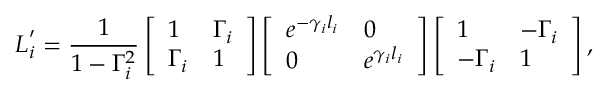Convert formula to latex. <formula><loc_0><loc_0><loc_500><loc_500>L _ { i } ^ { \prime } = \frac { 1 } { 1 - \Gamma _ { i } ^ { 2 } } \left [ \begin{array} { l l } { 1 } & { \Gamma _ { i } } \\ { \Gamma _ { i } } & { 1 } \end{array} \right ] \left [ \begin{array} { l l } { e ^ { - \gamma _ { i } l _ { i } } } & { 0 } \\ { 0 } & { e ^ { \gamma _ { i } l _ { i } } } \end{array} \right ] \left [ \begin{array} { l l } { 1 } & { - \Gamma _ { i } } \\ { - \Gamma _ { i } } & { 1 } \end{array} \right ] ,</formula> 